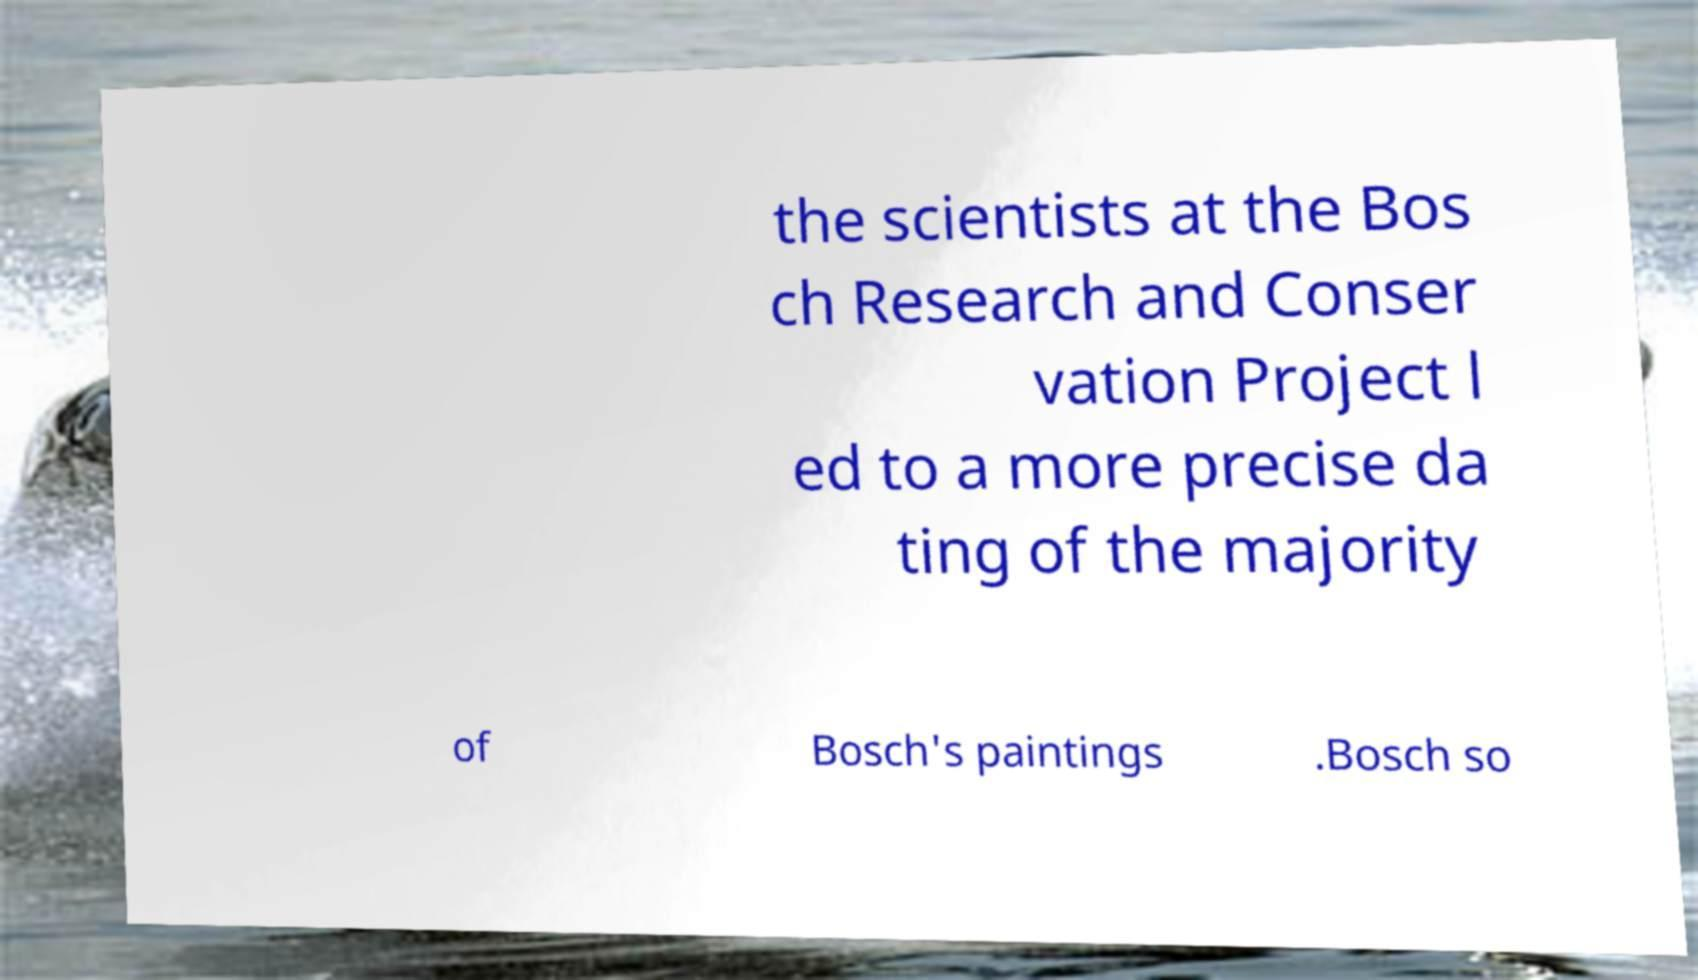Please identify and transcribe the text found in this image. the scientists at the Bos ch Research and Conser vation Project l ed to a more precise da ting of the majority of Bosch's paintings .Bosch so 